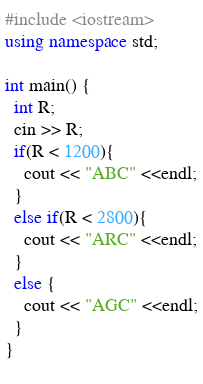Convert code to text. <code><loc_0><loc_0><loc_500><loc_500><_C++_>#include <iostream>
using namespace std;

int main() {
  int R;
  cin >> R;
  if(R < 1200){
    cout << "ABC" <<endl;
  }
  else if(R < 2800){
    cout << "ARC" <<endl;
  }
  else {
    cout << "AGC" <<endl;
  }
}
  </code> 